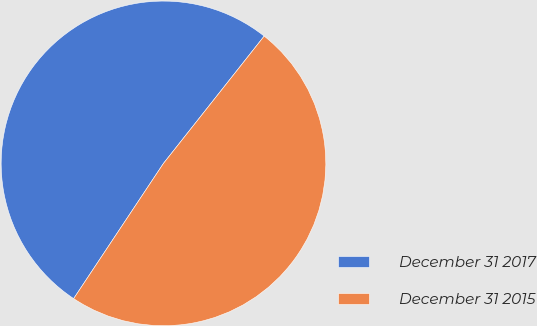<chart> <loc_0><loc_0><loc_500><loc_500><pie_chart><fcel>December 31 2017<fcel>December 31 2015<nl><fcel>51.32%<fcel>48.68%<nl></chart> 